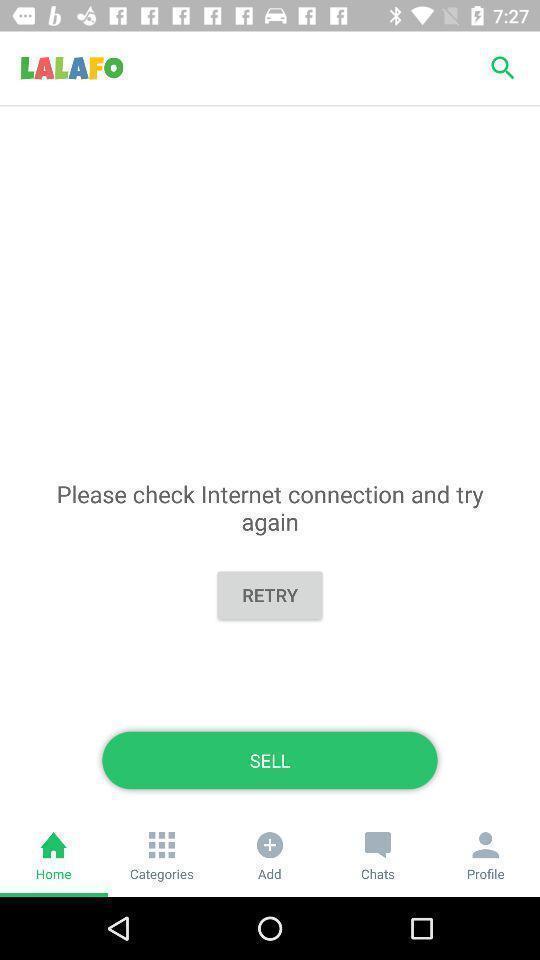Summarize the main components in this picture. Page shows different options. 